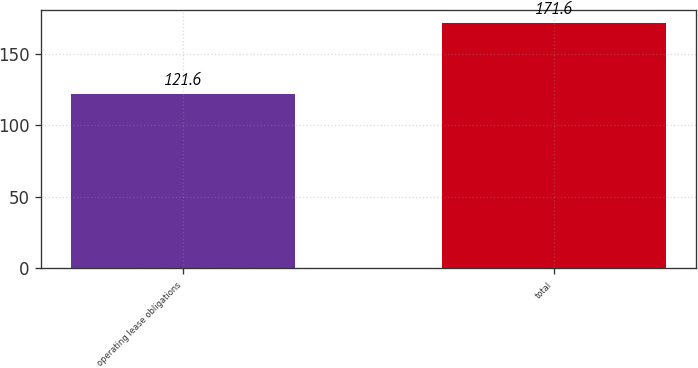Convert chart. <chart><loc_0><loc_0><loc_500><loc_500><bar_chart><fcel>operating lease obligations<fcel>total<nl><fcel>121.6<fcel>171.6<nl></chart> 